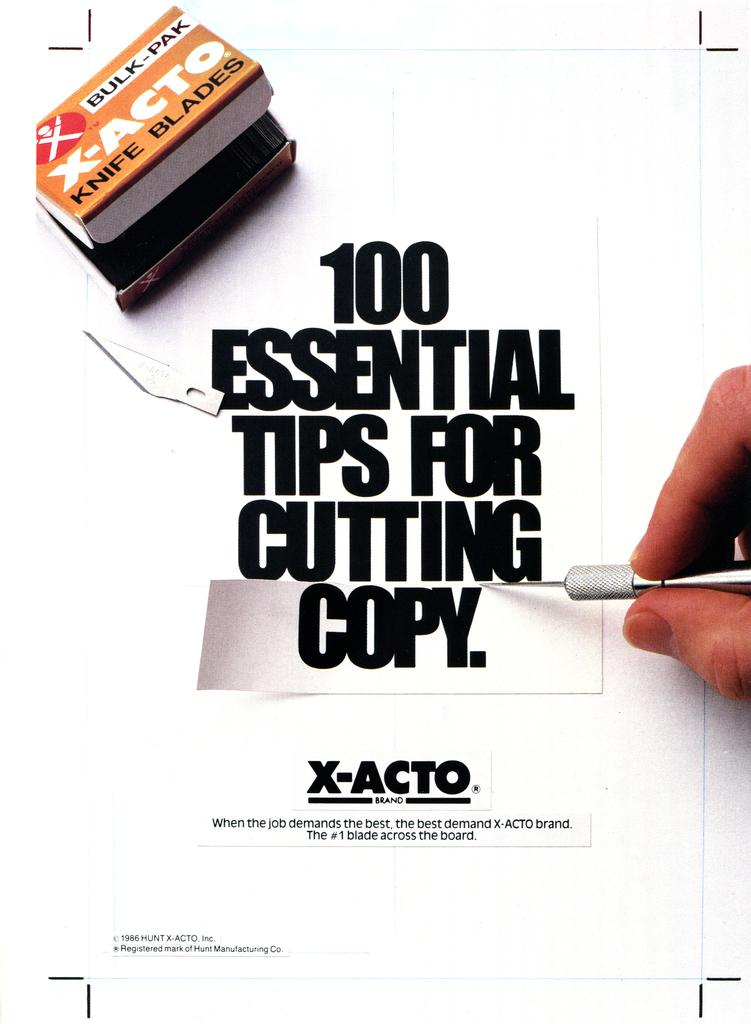What is featured on the poster in the image? There is a poster in the image, and it has text on it. Can you describe the object being held by the person's hand in the image? There is a person's hand holding an object on the right side of the image, but the object cannot be identified from the provided facts. What is located at the top of the image? There is a small box at the top of the image. Are there any ants crawling on the poster in the image? There is no mention of ants in the provided facts, so we cannot determine if there are any ants present in the image. 